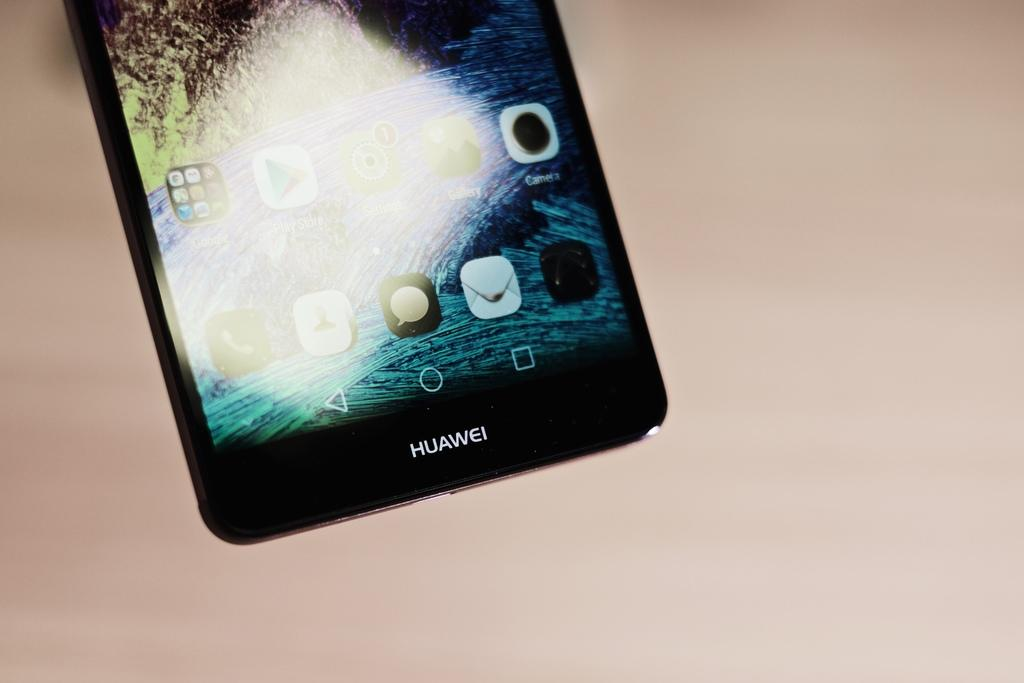<image>
Summarize the visual content of the image. An iphone with the word Huawei on the bottom 